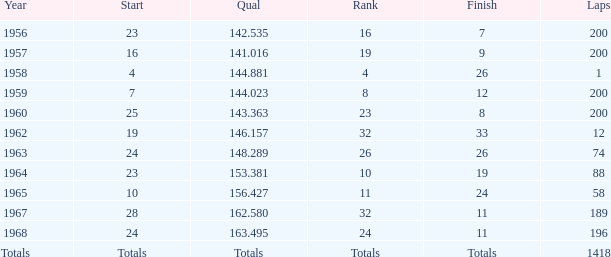What is the greatest quantity of laps that also results in a total of 8? 200.0. Give me the full table as a dictionary. {'header': ['Year', 'Start', 'Qual', 'Rank', 'Finish', 'Laps'], 'rows': [['1956', '23', '142.535', '16', '7', '200'], ['1957', '16', '141.016', '19', '9', '200'], ['1958', '4', '144.881', '4', '26', '1'], ['1959', '7', '144.023', '8', '12', '200'], ['1960', '25', '143.363', '23', '8', '200'], ['1962', '19', '146.157', '32', '33', '12'], ['1963', '24', '148.289', '26', '26', '74'], ['1964', '23', '153.381', '10', '19', '88'], ['1965', '10', '156.427', '11', '24', '58'], ['1967', '28', '162.580', '32', '11', '189'], ['1968', '24', '163.495', '24', '11', '196'], ['Totals', 'Totals', 'Totals', 'Totals', 'Totals', '1418']]} 